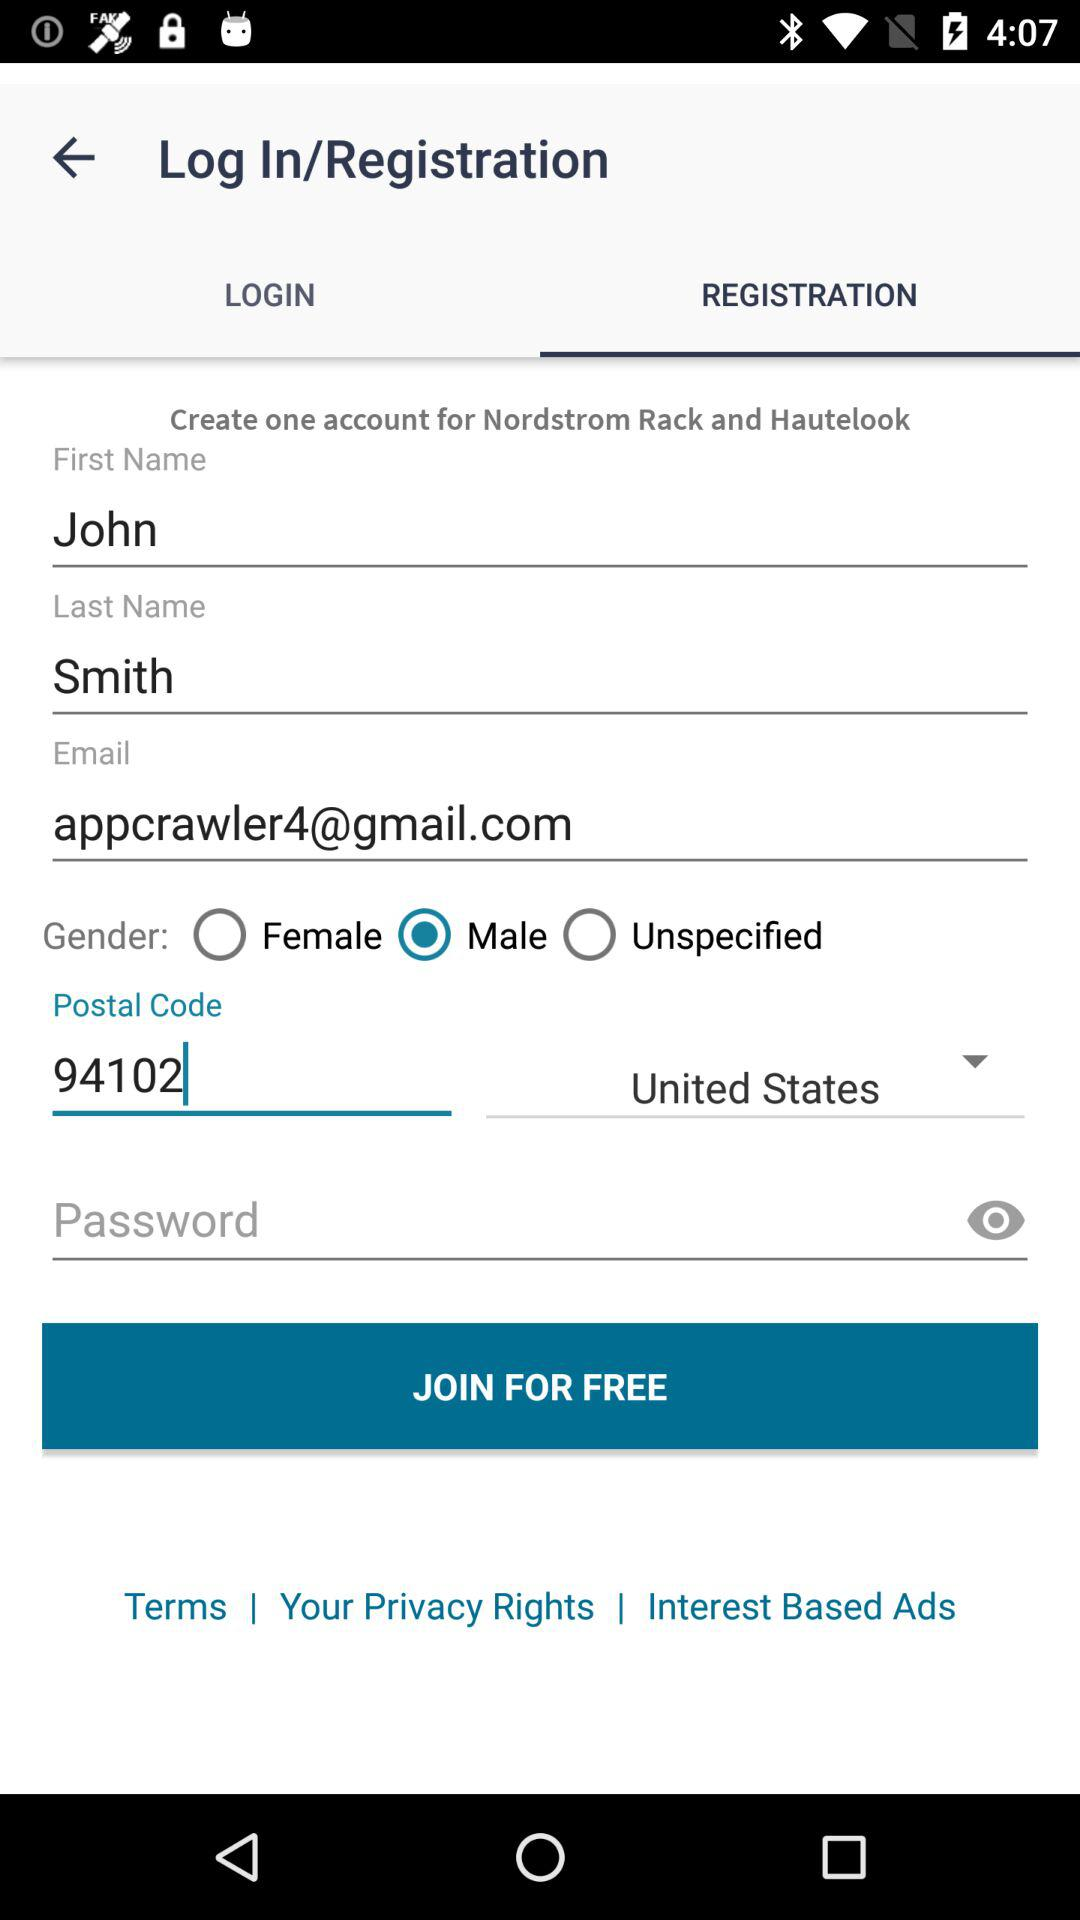What is the chosen gender? The chosen gender is male. 